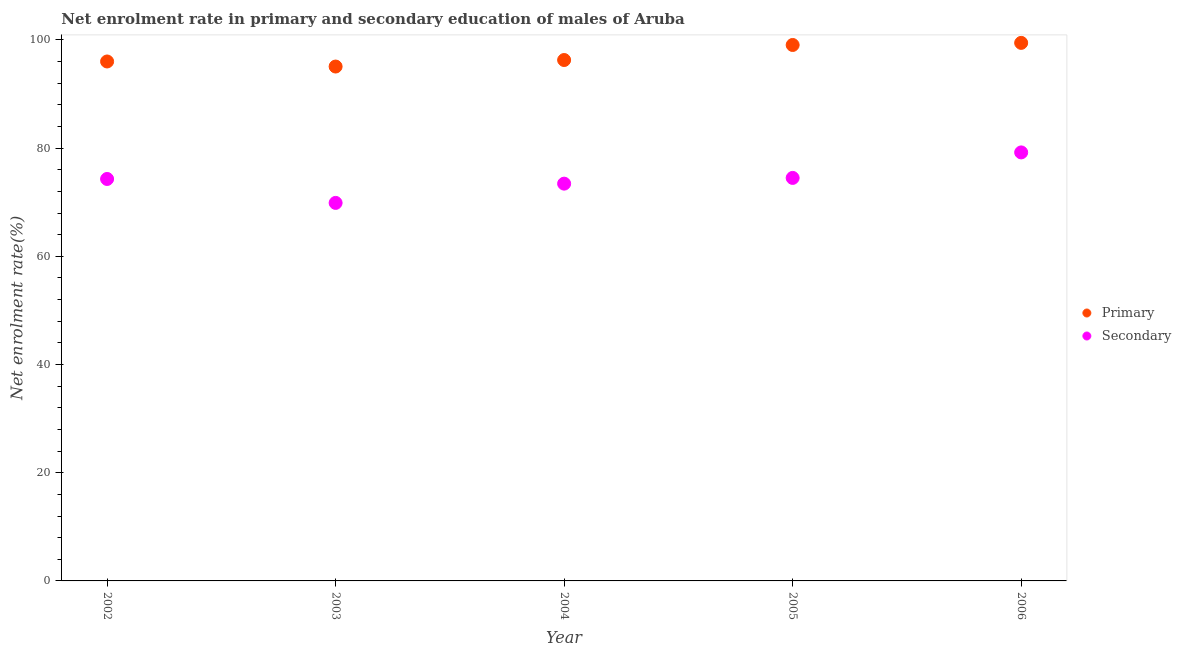How many different coloured dotlines are there?
Ensure brevity in your answer.  2. Is the number of dotlines equal to the number of legend labels?
Offer a very short reply. Yes. What is the enrollment rate in secondary education in 2005?
Ensure brevity in your answer.  74.49. Across all years, what is the maximum enrollment rate in primary education?
Keep it short and to the point. 99.46. Across all years, what is the minimum enrollment rate in primary education?
Provide a succinct answer. 95.08. In which year was the enrollment rate in primary education maximum?
Ensure brevity in your answer.  2006. In which year was the enrollment rate in secondary education minimum?
Your answer should be compact. 2003. What is the total enrollment rate in secondary education in the graph?
Give a very brief answer. 371.31. What is the difference between the enrollment rate in secondary education in 2002 and that in 2006?
Ensure brevity in your answer.  -4.91. What is the difference between the enrollment rate in secondary education in 2006 and the enrollment rate in primary education in 2005?
Make the answer very short. -19.86. What is the average enrollment rate in primary education per year?
Give a very brief answer. 97.18. In the year 2003, what is the difference between the enrollment rate in secondary education and enrollment rate in primary education?
Your answer should be compact. -25.21. In how many years, is the enrollment rate in secondary education greater than 16 %?
Offer a terse response. 5. What is the ratio of the enrollment rate in secondary education in 2002 to that in 2005?
Give a very brief answer. 1. What is the difference between the highest and the second highest enrollment rate in secondary education?
Keep it short and to the point. 4.71. What is the difference between the highest and the lowest enrollment rate in secondary education?
Provide a succinct answer. 9.33. In how many years, is the enrollment rate in secondary education greater than the average enrollment rate in secondary education taken over all years?
Make the answer very short. 3. Is the sum of the enrollment rate in primary education in 2002 and 2005 greater than the maximum enrollment rate in secondary education across all years?
Provide a succinct answer. Yes. Does the enrollment rate in primary education monotonically increase over the years?
Provide a short and direct response. No. Is the enrollment rate in primary education strictly less than the enrollment rate in secondary education over the years?
Ensure brevity in your answer.  No. How many dotlines are there?
Ensure brevity in your answer.  2. Are the values on the major ticks of Y-axis written in scientific E-notation?
Ensure brevity in your answer.  No. Does the graph contain grids?
Provide a short and direct response. No. Where does the legend appear in the graph?
Provide a short and direct response. Center right. How many legend labels are there?
Provide a short and direct response. 2. What is the title of the graph?
Your response must be concise. Net enrolment rate in primary and secondary education of males of Aruba. Does "Exports" appear as one of the legend labels in the graph?
Your response must be concise. No. What is the label or title of the Y-axis?
Provide a short and direct response. Net enrolment rate(%). What is the Net enrolment rate(%) in Primary in 2002?
Your answer should be compact. 96.02. What is the Net enrolment rate(%) of Secondary in 2002?
Provide a short and direct response. 74.3. What is the Net enrolment rate(%) of Primary in 2003?
Make the answer very short. 95.08. What is the Net enrolment rate(%) of Secondary in 2003?
Offer a terse response. 69.87. What is the Net enrolment rate(%) of Primary in 2004?
Give a very brief answer. 96.29. What is the Net enrolment rate(%) of Secondary in 2004?
Offer a very short reply. 73.43. What is the Net enrolment rate(%) in Primary in 2005?
Your answer should be very brief. 99.07. What is the Net enrolment rate(%) in Secondary in 2005?
Make the answer very short. 74.49. What is the Net enrolment rate(%) of Primary in 2006?
Make the answer very short. 99.46. What is the Net enrolment rate(%) in Secondary in 2006?
Ensure brevity in your answer.  79.21. Across all years, what is the maximum Net enrolment rate(%) of Primary?
Your answer should be very brief. 99.46. Across all years, what is the maximum Net enrolment rate(%) of Secondary?
Your answer should be very brief. 79.21. Across all years, what is the minimum Net enrolment rate(%) in Primary?
Offer a terse response. 95.08. Across all years, what is the minimum Net enrolment rate(%) of Secondary?
Offer a terse response. 69.87. What is the total Net enrolment rate(%) of Primary in the graph?
Give a very brief answer. 485.91. What is the total Net enrolment rate(%) of Secondary in the graph?
Keep it short and to the point. 371.31. What is the difference between the Net enrolment rate(%) of Primary in 2002 and that in 2003?
Provide a succinct answer. 0.94. What is the difference between the Net enrolment rate(%) in Secondary in 2002 and that in 2003?
Provide a short and direct response. 4.42. What is the difference between the Net enrolment rate(%) of Primary in 2002 and that in 2004?
Offer a very short reply. -0.27. What is the difference between the Net enrolment rate(%) of Secondary in 2002 and that in 2004?
Your answer should be very brief. 0.86. What is the difference between the Net enrolment rate(%) of Primary in 2002 and that in 2005?
Your response must be concise. -3.05. What is the difference between the Net enrolment rate(%) of Secondary in 2002 and that in 2005?
Give a very brief answer. -0.2. What is the difference between the Net enrolment rate(%) in Primary in 2002 and that in 2006?
Your response must be concise. -3.44. What is the difference between the Net enrolment rate(%) in Secondary in 2002 and that in 2006?
Offer a very short reply. -4.91. What is the difference between the Net enrolment rate(%) in Primary in 2003 and that in 2004?
Make the answer very short. -1.21. What is the difference between the Net enrolment rate(%) in Secondary in 2003 and that in 2004?
Ensure brevity in your answer.  -3.56. What is the difference between the Net enrolment rate(%) in Primary in 2003 and that in 2005?
Offer a very short reply. -3.99. What is the difference between the Net enrolment rate(%) of Secondary in 2003 and that in 2005?
Ensure brevity in your answer.  -4.62. What is the difference between the Net enrolment rate(%) in Primary in 2003 and that in 2006?
Keep it short and to the point. -4.37. What is the difference between the Net enrolment rate(%) of Secondary in 2003 and that in 2006?
Keep it short and to the point. -9.33. What is the difference between the Net enrolment rate(%) of Primary in 2004 and that in 2005?
Give a very brief answer. -2.78. What is the difference between the Net enrolment rate(%) in Secondary in 2004 and that in 2005?
Your answer should be very brief. -1.06. What is the difference between the Net enrolment rate(%) in Primary in 2004 and that in 2006?
Ensure brevity in your answer.  -3.17. What is the difference between the Net enrolment rate(%) in Secondary in 2004 and that in 2006?
Offer a terse response. -5.77. What is the difference between the Net enrolment rate(%) of Primary in 2005 and that in 2006?
Offer a terse response. -0.39. What is the difference between the Net enrolment rate(%) in Secondary in 2005 and that in 2006?
Make the answer very short. -4.71. What is the difference between the Net enrolment rate(%) in Primary in 2002 and the Net enrolment rate(%) in Secondary in 2003?
Your answer should be very brief. 26.14. What is the difference between the Net enrolment rate(%) of Primary in 2002 and the Net enrolment rate(%) of Secondary in 2004?
Your answer should be compact. 22.58. What is the difference between the Net enrolment rate(%) in Primary in 2002 and the Net enrolment rate(%) in Secondary in 2005?
Your response must be concise. 21.52. What is the difference between the Net enrolment rate(%) of Primary in 2002 and the Net enrolment rate(%) of Secondary in 2006?
Your response must be concise. 16.81. What is the difference between the Net enrolment rate(%) of Primary in 2003 and the Net enrolment rate(%) of Secondary in 2004?
Your answer should be very brief. 21.65. What is the difference between the Net enrolment rate(%) of Primary in 2003 and the Net enrolment rate(%) of Secondary in 2005?
Keep it short and to the point. 20.59. What is the difference between the Net enrolment rate(%) in Primary in 2003 and the Net enrolment rate(%) in Secondary in 2006?
Keep it short and to the point. 15.87. What is the difference between the Net enrolment rate(%) of Primary in 2004 and the Net enrolment rate(%) of Secondary in 2005?
Keep it short and to the point. 21.79. What is the difference between the Net enrolment rate(%) of Primary in 2004 and the Net enrolment rate(%) of Secondary in 2006?
Offer a very short reply. 17.08. What is the difference between the Net enrolment rate(%) of Primary in 2005 and the Net enrolment rate(%) of Secondary in 2006?
Keep it short and to the point. 19.86. What is the average Net enrolment rate(%) in Primary per year?
Your response must be concise. 97.18. What is the average Net enrolment rate(%) of Secondary per year?
Offer a very short reply. 74.26. In the year 2002, what is the difference between the Net enrolment rate(%) in Primary and Net enrolment rate(%) in Secondary?
Make the answer very short. 21.72. In the year 2003, what is the difference between the Net enrolment rate(%) of Primary and Net enrolment rate(%) of Secondary?
Provide a succinct answer. 25.21. In the year 2004, what is the difference between the Net enrolment rate(%) of Primary and Net enrolment rate(%) of Secondary?
Make the answer very short. 22.85. In the year 2005, what is the difference between the Net enrolment rate(%) in Primary and Net enrolment rate(%) in Secondary?
Your answer should be compact. 24.57. In the year 2006, what is the difference between the Net enrolment rate(%) in Primary and Net enrolment rate(%) in Secondary?
Provide a succinct answer. 20.25. What is the ratio of the Net enrolment rate(%) of Primary in 2002 to that in 2003?
Make the answer very short. 1.01. What is the ratio of the Net enrolment rate(%) in Secondary in 2002 to that in 2003?
Offer a terse response. 1.06. What is the ratio of the Net enrolment rate(%) of Primary in 2002 to that in 2004?
Keep it short and to the point. 1. What is the ratio of the Net enrolment rate(%) in Secondary in 2002 to that in 2004?
Your answer should be compact. 1.01. What is the ratio of the Net enrolment rate(%) in Primary in 2002 to that in 2005?
Provide a succinct answer. 0.97. What is the ratio of the Net enrolment rate(%) of Primary in 2002 to that in 2006?
Make the answer very short. 0.97. What is the ratio of the Net enrolment rate(%) in Secondary in 2002 to that in 2006?
Offer a very short reply. 0.94. What is the ratio of the Net enrolment rate(%) of Primary in 2003 to that in 2004?
Ensure brevity in your answer.  0.99. What is the ratio of the Net enrolment rate(%) of Secondary in 2003 to that in 2004?
Provide a succinct answer. 0.95. What is the ratio of the Net enrolment rate(%) in Primary in 2003 to that in 2005?
Provide a succinct answer. 0.96. What is the ratio of the Net enrolment rate(%) in Secondary in 2003 to that in 2005?
Provide a short and direct response. 0.94. What is the ratio of the Net enrolment rate(%) of Primary in 2003 to that in 2006?
Keep it short and to the point. 0.96. What is the ratio of the Net enrolment rate(%) in Secondary in 2003 to that in 2006?
Give a very brief answer. 0.88. What is the ratio of the Net enrolment rate(%) in Primary in 2004 to that in 2005?
Give a very brief answer. 0.97. What is the ratio of the Net enrolment rate(%) of Secondary in 2004 to that in 2005?
Your answer should be very brief. 0.99. What is the ratio of the Net enrolment rate(%) of Primary in 2004 to that in 2006?
Make the answer very short. 0.97. What is the ratio of the Net enrolment rate(%) in Secondary in 2004 to that in 2006?
Your answer should be compact. 0.93. What is the ratio of the Net enrolment rate(%) of Primary in 2005 to that in 2006?
Provide a succinct answer. 1. What is the ratio of the Net enrolment rate(%) of Secondary in 2005 to that in 2006?
Offer a very short reply. 0.94. What is the difference between the highest and the second highest Net enrolment rate(%) of Primary?
Offer a terse response. 0.39. What is the difference between the highest and the second highest Net enrolment rate(%) of Secondary?
Ensure brevity in your answer.  4.71. What is the difference between the highest and the lowest Net enrolment rate(%) of Primary?
Your answer should be very brief. 4.37. What is the difference between the highest and the lowest Net enrolment rate(%) in Secondary?
Provide a succinct answer. 9.33. 